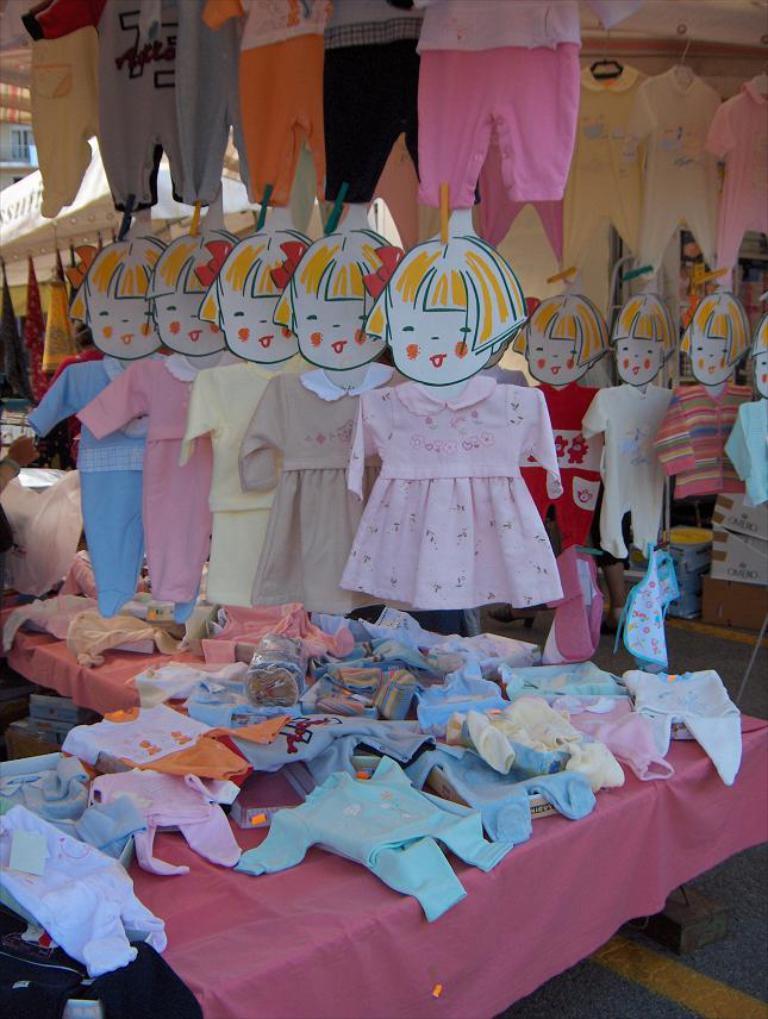Describe this image in one or two sentences. In the foreground of this picture, we see clothes on table. On right and on top, we see clothes hanging to the ceiling. In the background, we see a window of a building. 